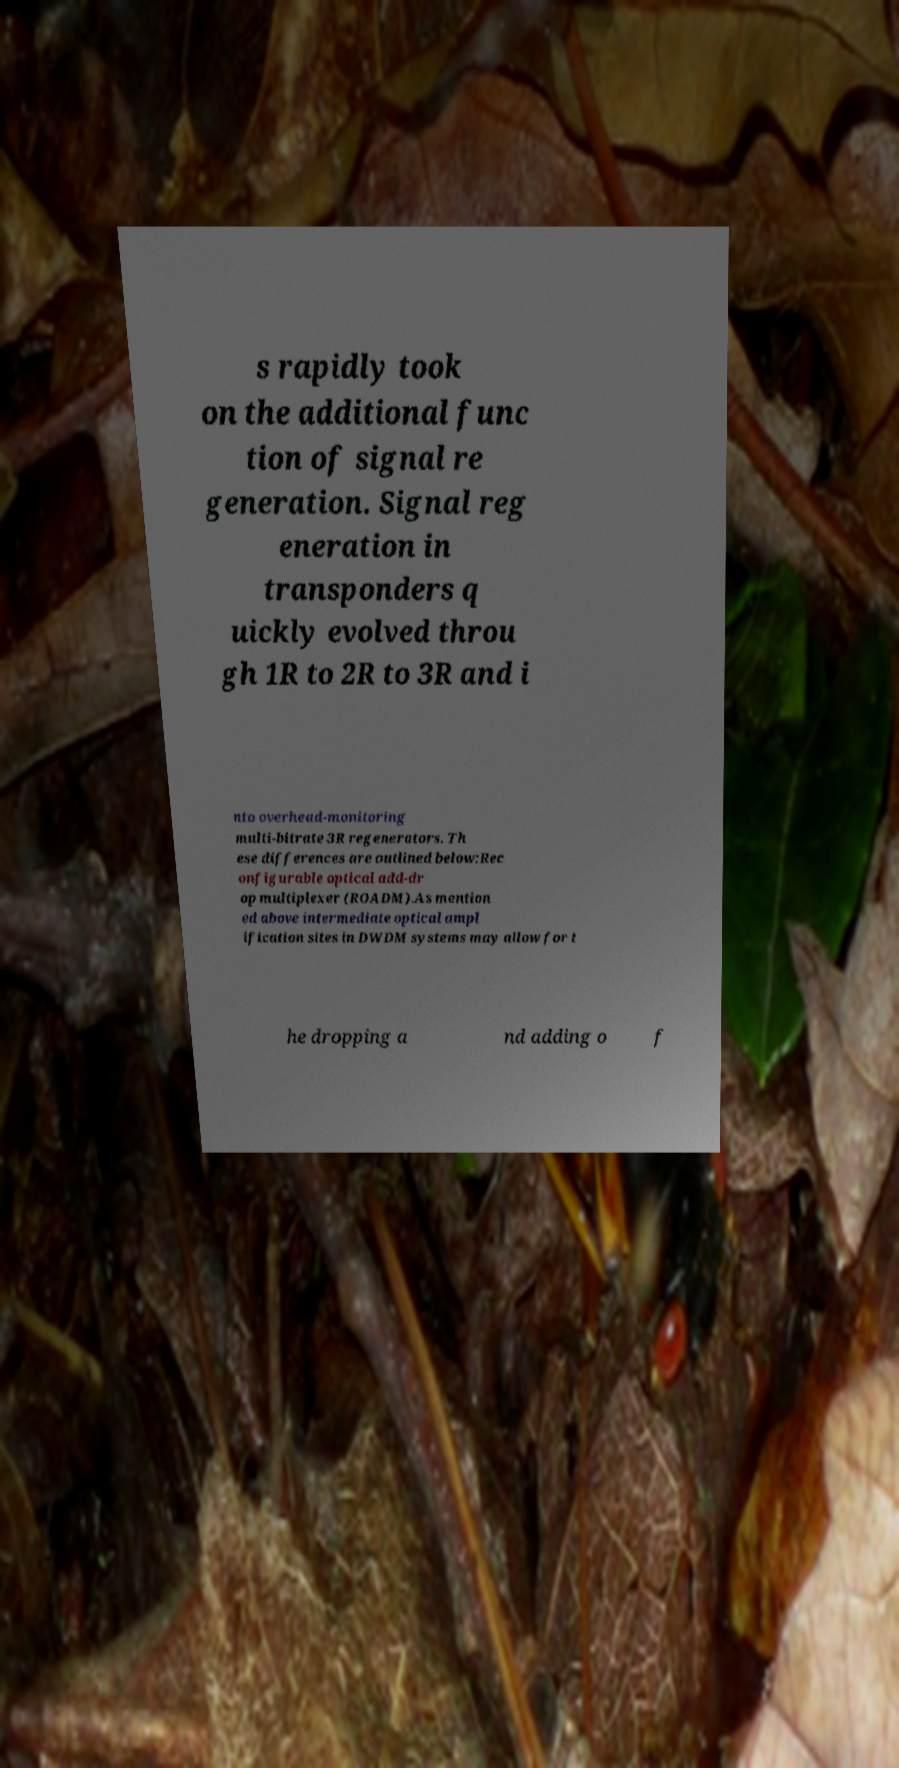I need the written content from this picture converted into text. Can you do that? s rapidly took on the additional func tion of signal re generation. Signal reg eneration in transponders q uickly evolved throu gh 1R to 2R to 3R and i nto overhead-monitoring multi-bitrate 3R regenerators. Th ese differences are outlined below:Rec onfigurable optical add-dr op multiplexer (ROADM).As mention ed above intermediate optical ampl ification sites in DWDM systems may allow for t he dropping a nd adding o f 